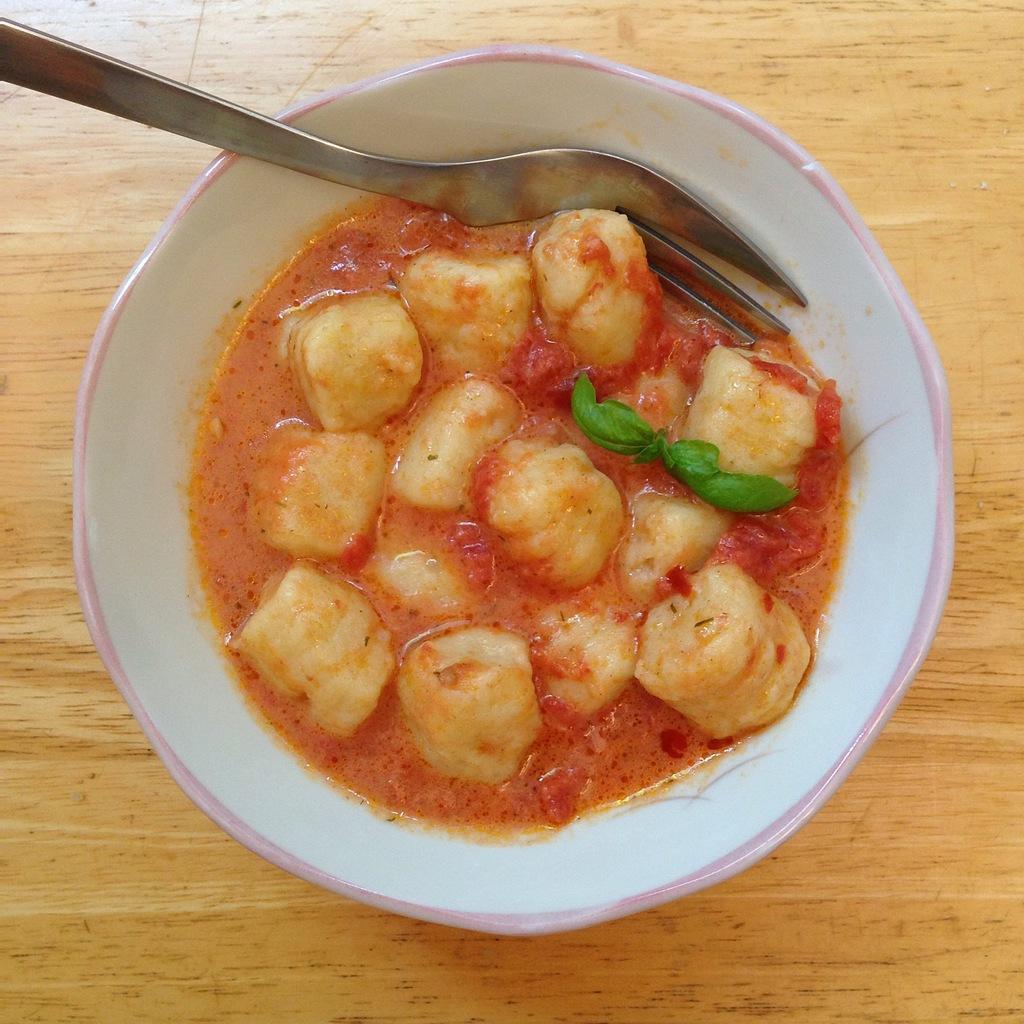Could you give a brief overview of what you see in this image? Here we can see a food item and a spoon in a bowl on a platform. 